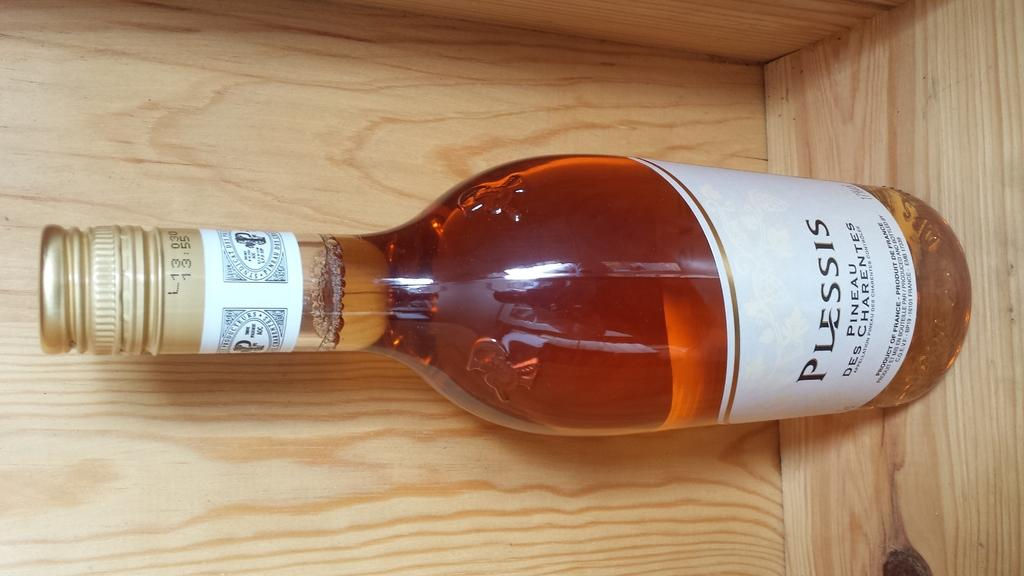<image>
Write a terse but informative summary of the picture. A bottle of wine called Plessis sits on a shelf/ 